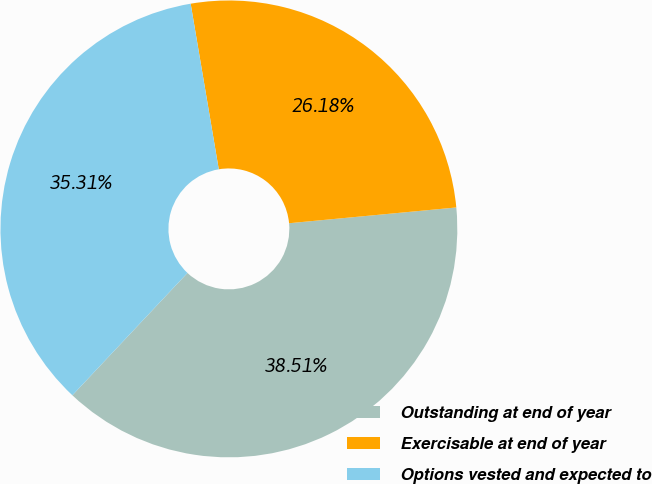Convert chart to OTSL. <chart><loc_0><loc_0><loc_500><loc_500><pie_chart><fcel>Outstanding at end of year<fcel>Exercisable at end of year<fcel>Options vested and expected to<nl><fcel>38.51%<fcel>26.18%<fcel>35.31%<nl></chart> 